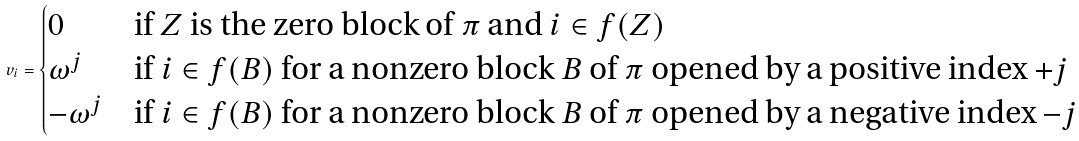Convert formula to latex. <formula><loc_0><loc_0><loc_500><loc_500>v _ { i } = \begin{cases} 0 & \text {if $Z$ is the zero block of $\pi$ and $i \in f(Z)$} \\ \omega ^ { j } & \text {if $i \in f(B)$ for a nonzero block $B$ of $\pi$ opened by a positive index $+j$} \\ - \omega ^ { j } & \text {if $i \in f(B)$ for a nonzero block $B$ of $\pi$ opened by a negative index $-j$} \end{cases}</formula> 